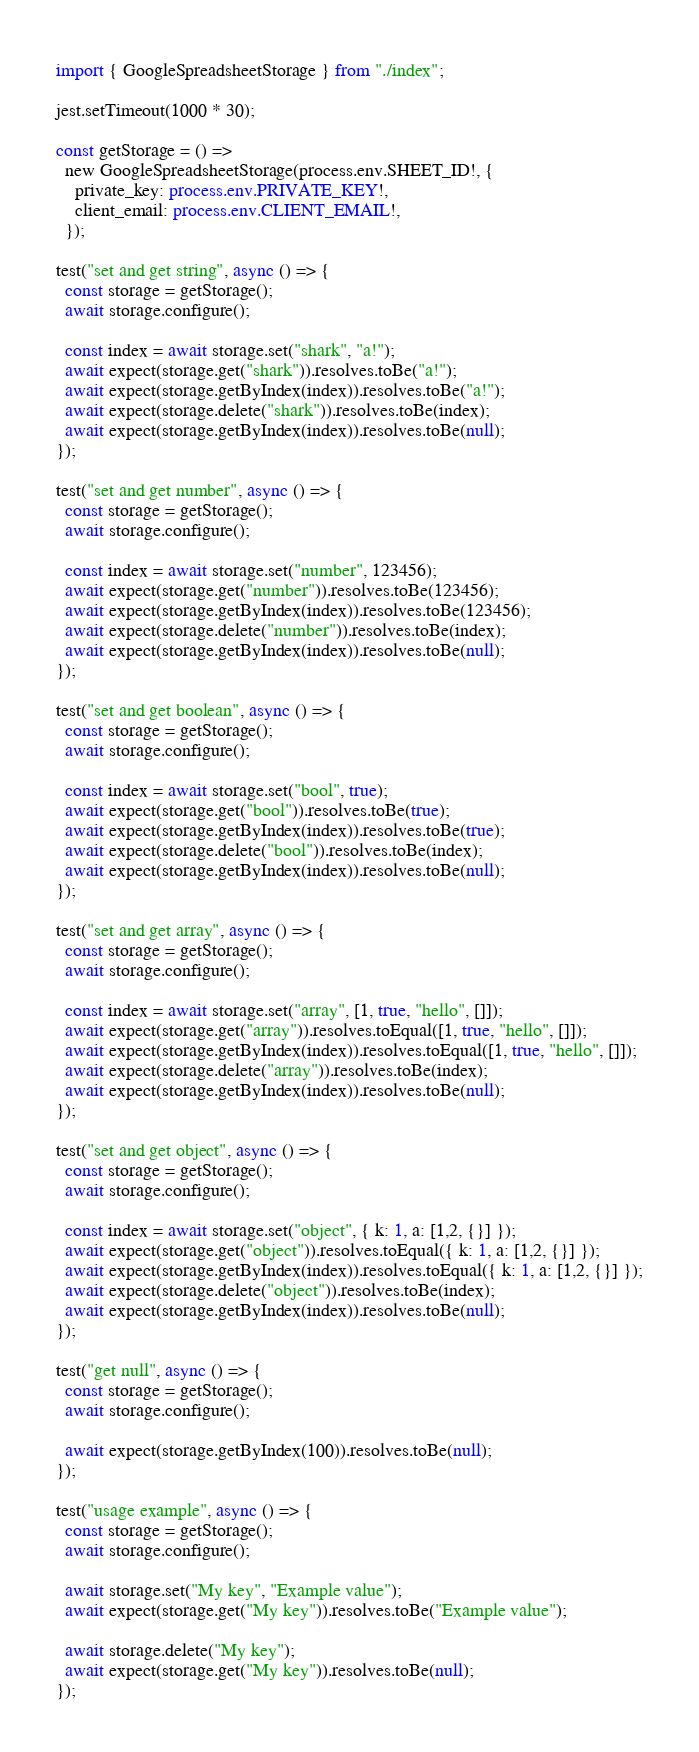<code> <loc_0><loc_0><loc_500><loc_500><_TypeScript_>import { GoogleSpreadsheetStorage } from "./index";

jest.setTimeout(1000 * 30);

const getStorage = () =>
  new GoogleSpreadsheetStorage(process.env.SHEET_ID!, {
    private_key: process.env.PRIVATE_KEY!,
    client_email: process.env.CLIENT_EMAIL!,
  });

test("set and get string", async () => {
  const storage = getStorage();
  await storage.configure();

  const index = await storage.set("shark", "a!");
  await expect(storage.get("shark")).resolves.toBe("a!");
  await expect(storage.getByIndex(index)).resolves.toBe("a!");
  await expect(storage.delete("shark")).resolves.toBe(index);
  await expect(storage.getByIndex(index)).resolves.toBe(null);
});

test("set and get number", async () => {
  const storage = getStorage();
  await storage.configure();

  const index = await storage.set("number", 123456);
  await expect(storage.get("number")).resolves.toBe(123456);
  await expect(storage.getByIndex(index)).resolves.toBe(123456);
  await expect(storage.delete("number")).resolves.toBe(index);
  await expect(storage.getByIndex(index)).resolves.toBe(null);
});

test("set and get boolean", async () => {
  const storage = getStorage();
  await storage.configure();

  const index = await storage.set("bool", true);
  await expect(storage.get("bool")).resolves.toBe(true);
  await expect(storage.getByIndex(index)).resolves.toBe(true);
  await expect(storage.delete("bool")).resolves.toBe(index);
  await expect(storage.getByIndex(index)).resolves.toBe(null);
});

test("set and get array", async () => {
  const storage = getStorage();
  await storage.configure();

  const index = await storage.set("array", [1, true, "hello", []]);
  await expect(storage.get("array")).resolves.toEqual([1, true, "hello", []]);
  await expect(storage.getByIndex(index)).resolves.toEqual([1, true, "hello", []]);
  await expect(storage.delete("array")).resolves.toBe(index);
  await expect(storage.getByIndex(index)).resolves.toBe(null);
});

test("set and get object", async () => {
  const storage = getStorage();
  await storage.configure();

  const index = await storage.set("object", { k: 1, a: [1,2, {}] });
  await expect(storage.get("object")).resolves.toEqual({ k: 1, a: [1,2, {}] });
  await expect(storage.getByIndex(index)).resolves.toEqual({ k: 1, a: [1,2, {}] });
  await expect(storage.delete("object")).resolves.toBe(index);
  await expect(storage.getByIndex(index)).resolves.toBe(null);
});

test("get null", async () => {
  const storage = getStorage();
  await storage.configure();

  await expect(storage.getByIndex(100)).resolves.toBe(null);
});

test("usage example", async () => {
  const storage = getStorage();
  await storage.configure();

  await storage.set("My key", "Example value");
  await expect(storage.get("My key")).resolves.toBe("Example value");

  await storage.delete("My key");
  await expect(storage.get("My key")).resolves.toBe(null);
});
</code> 